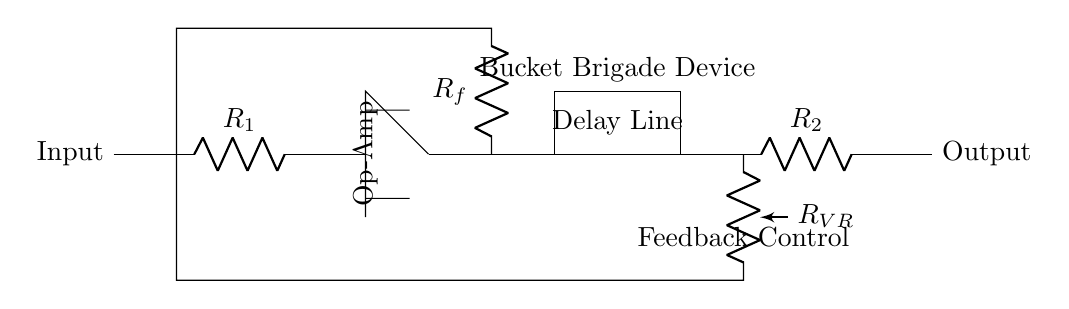What is the resistance value of R1? The circuit diagram does not specify a numerical value for R1. It is labeled simply as R1, indicating it's a resistor, but its value would have to be determined based on external specifications or designs.
Answer: R1 What component is used for delay? The delay function in the circuit is performed by the 'Delay Line', which is explicitly labeled in the diagram, indicating it acts as a medium to introduce a delay in the signal processing chain.
Answer: Delay Line What is the function of Rf in the circuit? The resistor Rf serves as a feedback resistor in the operational amplifier circuit. It creates a feedback loop that helps control the gain and stability of the op-amp by determining how much output is fed back to the input.
Answer: Feedback What does the variable resistor RVR control? The variable resistor RVR adjusts the feedback level in the circuit, influencing the intensity of the echo effect. By varying its resistance, it changes how much of the output signal is fed back into the input, altering the feedback ratio.
Answer: Feedback control What is located in the box labeled 'Delay Line'? In analog delay circuits, the 'Delay Line' typically contains components that create a time delay in the signal, often made from bucket brigade devices or analog delays circuits. This leads to the echo effect characteristic of guitar pedals.
Answer: Bucket Brigade Device Which component acts as the main amplification stage? The operational amplifier, indicated in the circuit with its label, is the main amplification stage. It amplifies the input signal before it is processed through the delay line and feedback components.
Answer: Op-Amp What is the output node labeled as? The output node is clearly marked as 'Output' in the diagram, representing the point where the processed signal, after passing through the delay line and resistors, exits the circuit.
Answer: Output 